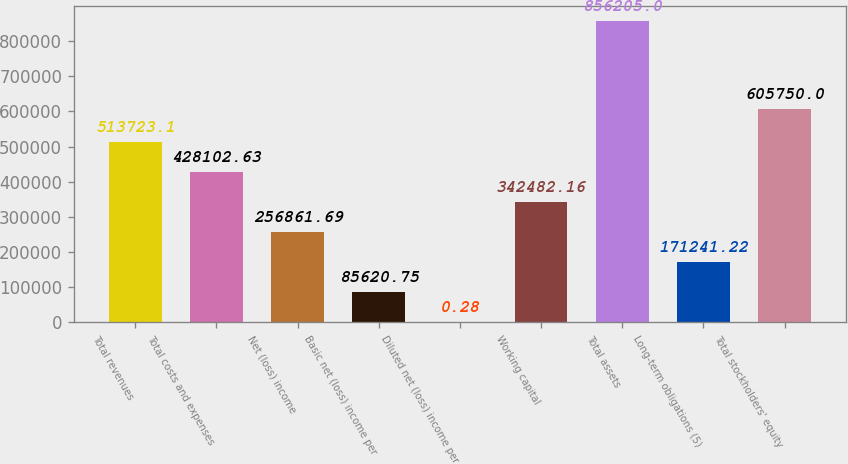Convert chart to OTSL. <chart><loc_0><loc_0><loc_500><loc_500><bar_chart><fcel>Total revenues<fcel>Total costs and expenses<fcel>Net (loss) income<fcel>Basic net (loss) income per<fcel>Diluted net (loss) income per<fcel>Working capital<fcel>Total assets<fcel>Long-term obligations (5)<fcel>Total stockholders' equity<nl><fcel>513723<fcel>428103<fcel>256862<fcel>85620.8<fcel>0.28<fcel>342482<fcel>856205<fcel>171241<fcel>605750<nl></chart> 